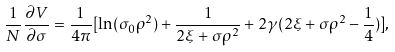<formula> <loc_0><loc_0><loc_500><loc_500>\frac { 1 } { N } \frac { \partial V } { \partial \sigma } = \frac { 1 } { 4 \pi } [ \ln ( \sigma _ { 0 } \rho ^ { 2 } ) + \frac { 1 } { 2 \xi + \sigma \rho ^ { 2 } } + 2 \gamma ( 2 \xi + \sigma \rho ^ { 2 } - \frac { 1 } { 4 } ) ] ,</formula> 